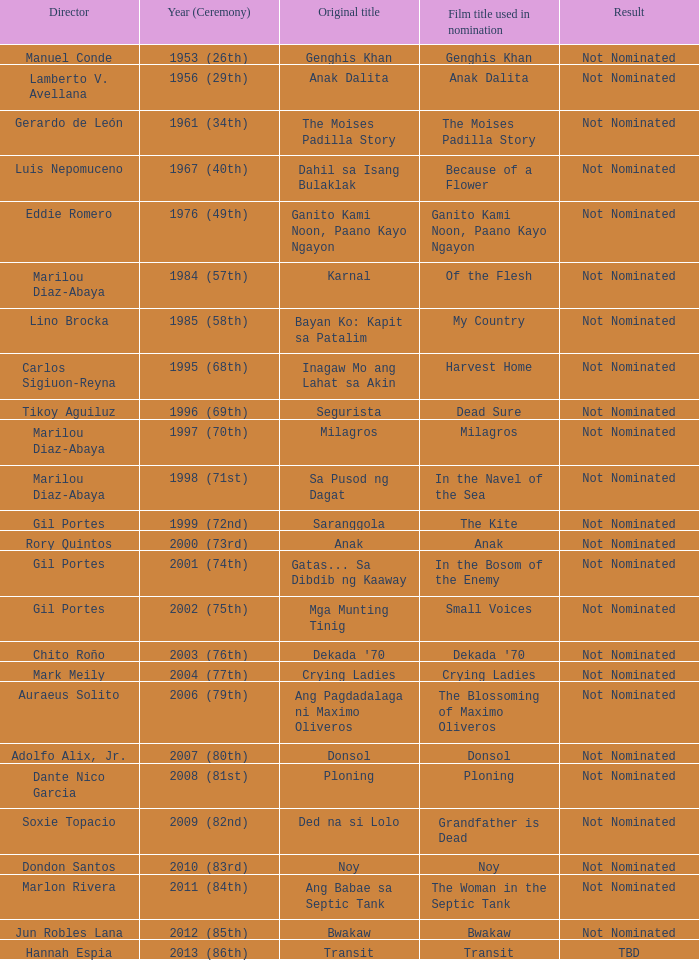Who was the director of Small Voices, a film title used in nomination? Gil Portes. 